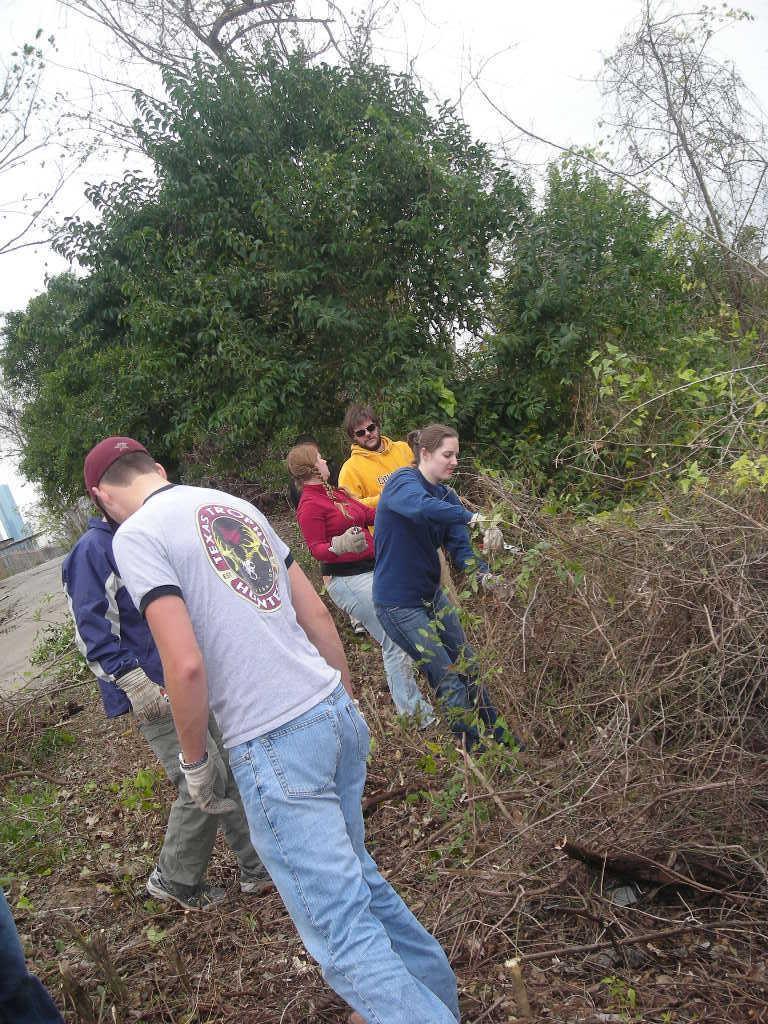Describe this image in one or two sentences. In this image there are people. On the right we can see pile of twigs. In the background there are trees and sky. 